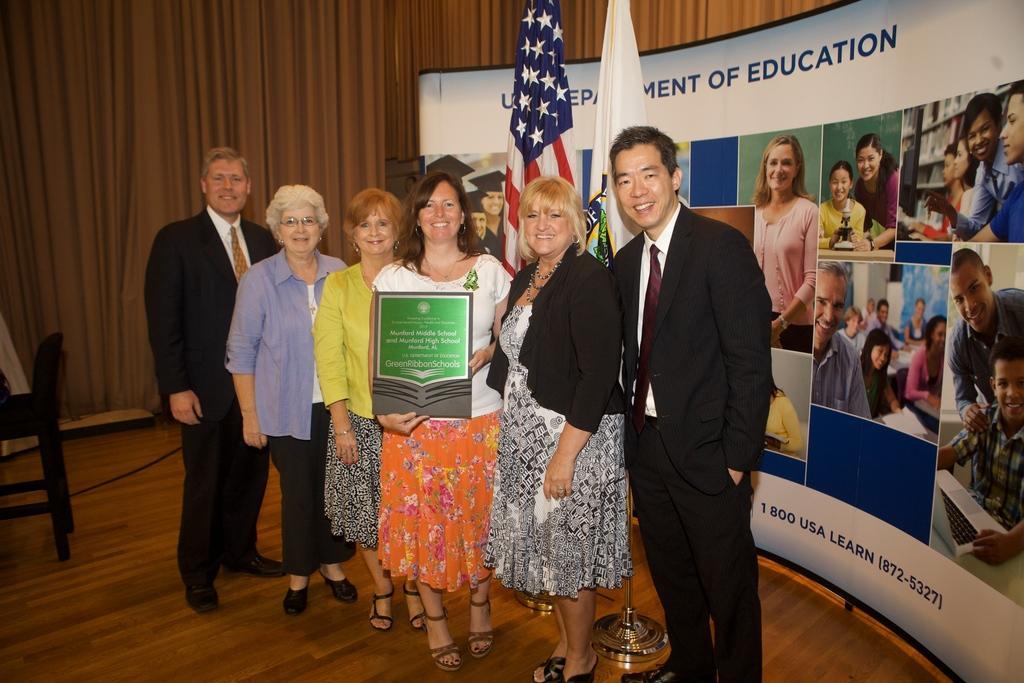Describe this image in one or two sentences. In this image we can see a group of people standing on the floor one person is wearing a black coat and tie. One woman is wearing a white t shirt is holding a shield in her hand. In the background, we can see a wall with some text and group of photos on it. Two flags and a chair on the floor and curtains. 